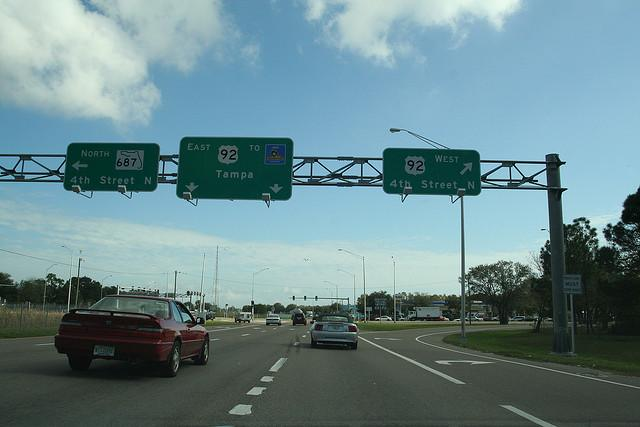What is the right lane used for? Please explain your reasoning. turns. The right lane has arrows painted on it showing that all those in that lane need to exit towards the right. 